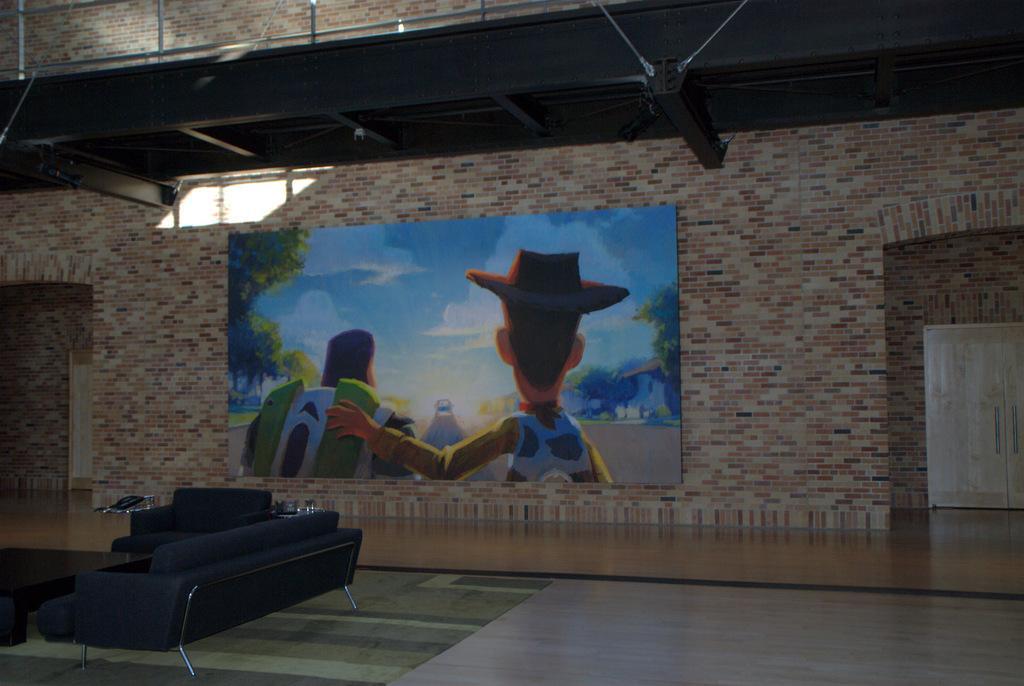Could you give a brief overview of what you see in this image? On the left side of the image we can see a table and sofas, in the background we can see a poster on the wall, and also we can find few metal rods. 